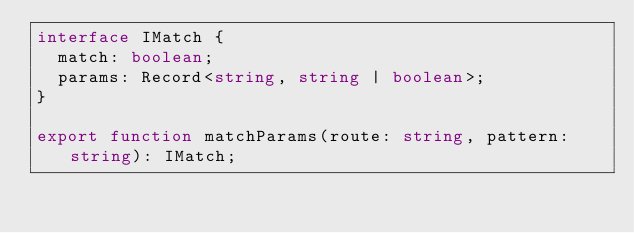<code> <loc_0><loc_0><loc_500><loc_500><_TypeScript_>interface IMatch {
  match: boolean;
  params: Record<string, string | boolean>;
}

export function matchParams(route: string, pattern: string): IMatch;
</code> 